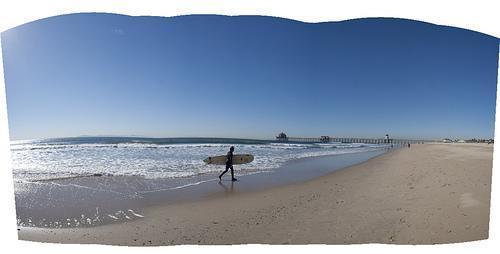How many people are carrying surfboards?
Give a very brief answer. 1. How many birds are in this picture?
Give a very brief answer. 0. 